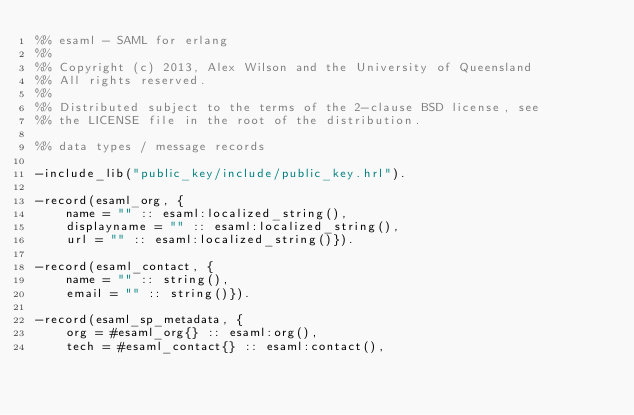Convert code to text. <code><loc_0><loc_0><loc_500><loc_500><_Erlang_>%% esaml - SAML for erlang
%%
%% Copyright (c) 2013, Alex Wilson and the University of Queensland
%% All rights reserved.
%%
%% Distributed subject to the terms of the 2-clause BSD license, see
%% the LICENSE file in the root of the distribution.

%% data types / message records

-include_lib("public_key/include/public_key.hrl").

-record(esaml_org, {
	name = "" :: esaml:localized_string(),
	displayname = "" :: esaml:localized_string(),
	url = "" :: esaml:localized_string()}).

-record(esaml_contact, {
	name = "" :: string(),
	email = "" :: string()}).

-record(esaml_sp_metadata, {
	org = #esaml_org{} :: esaml:org(),
	tech = #esaml_contact{} :: esaml:contact(),</code> 